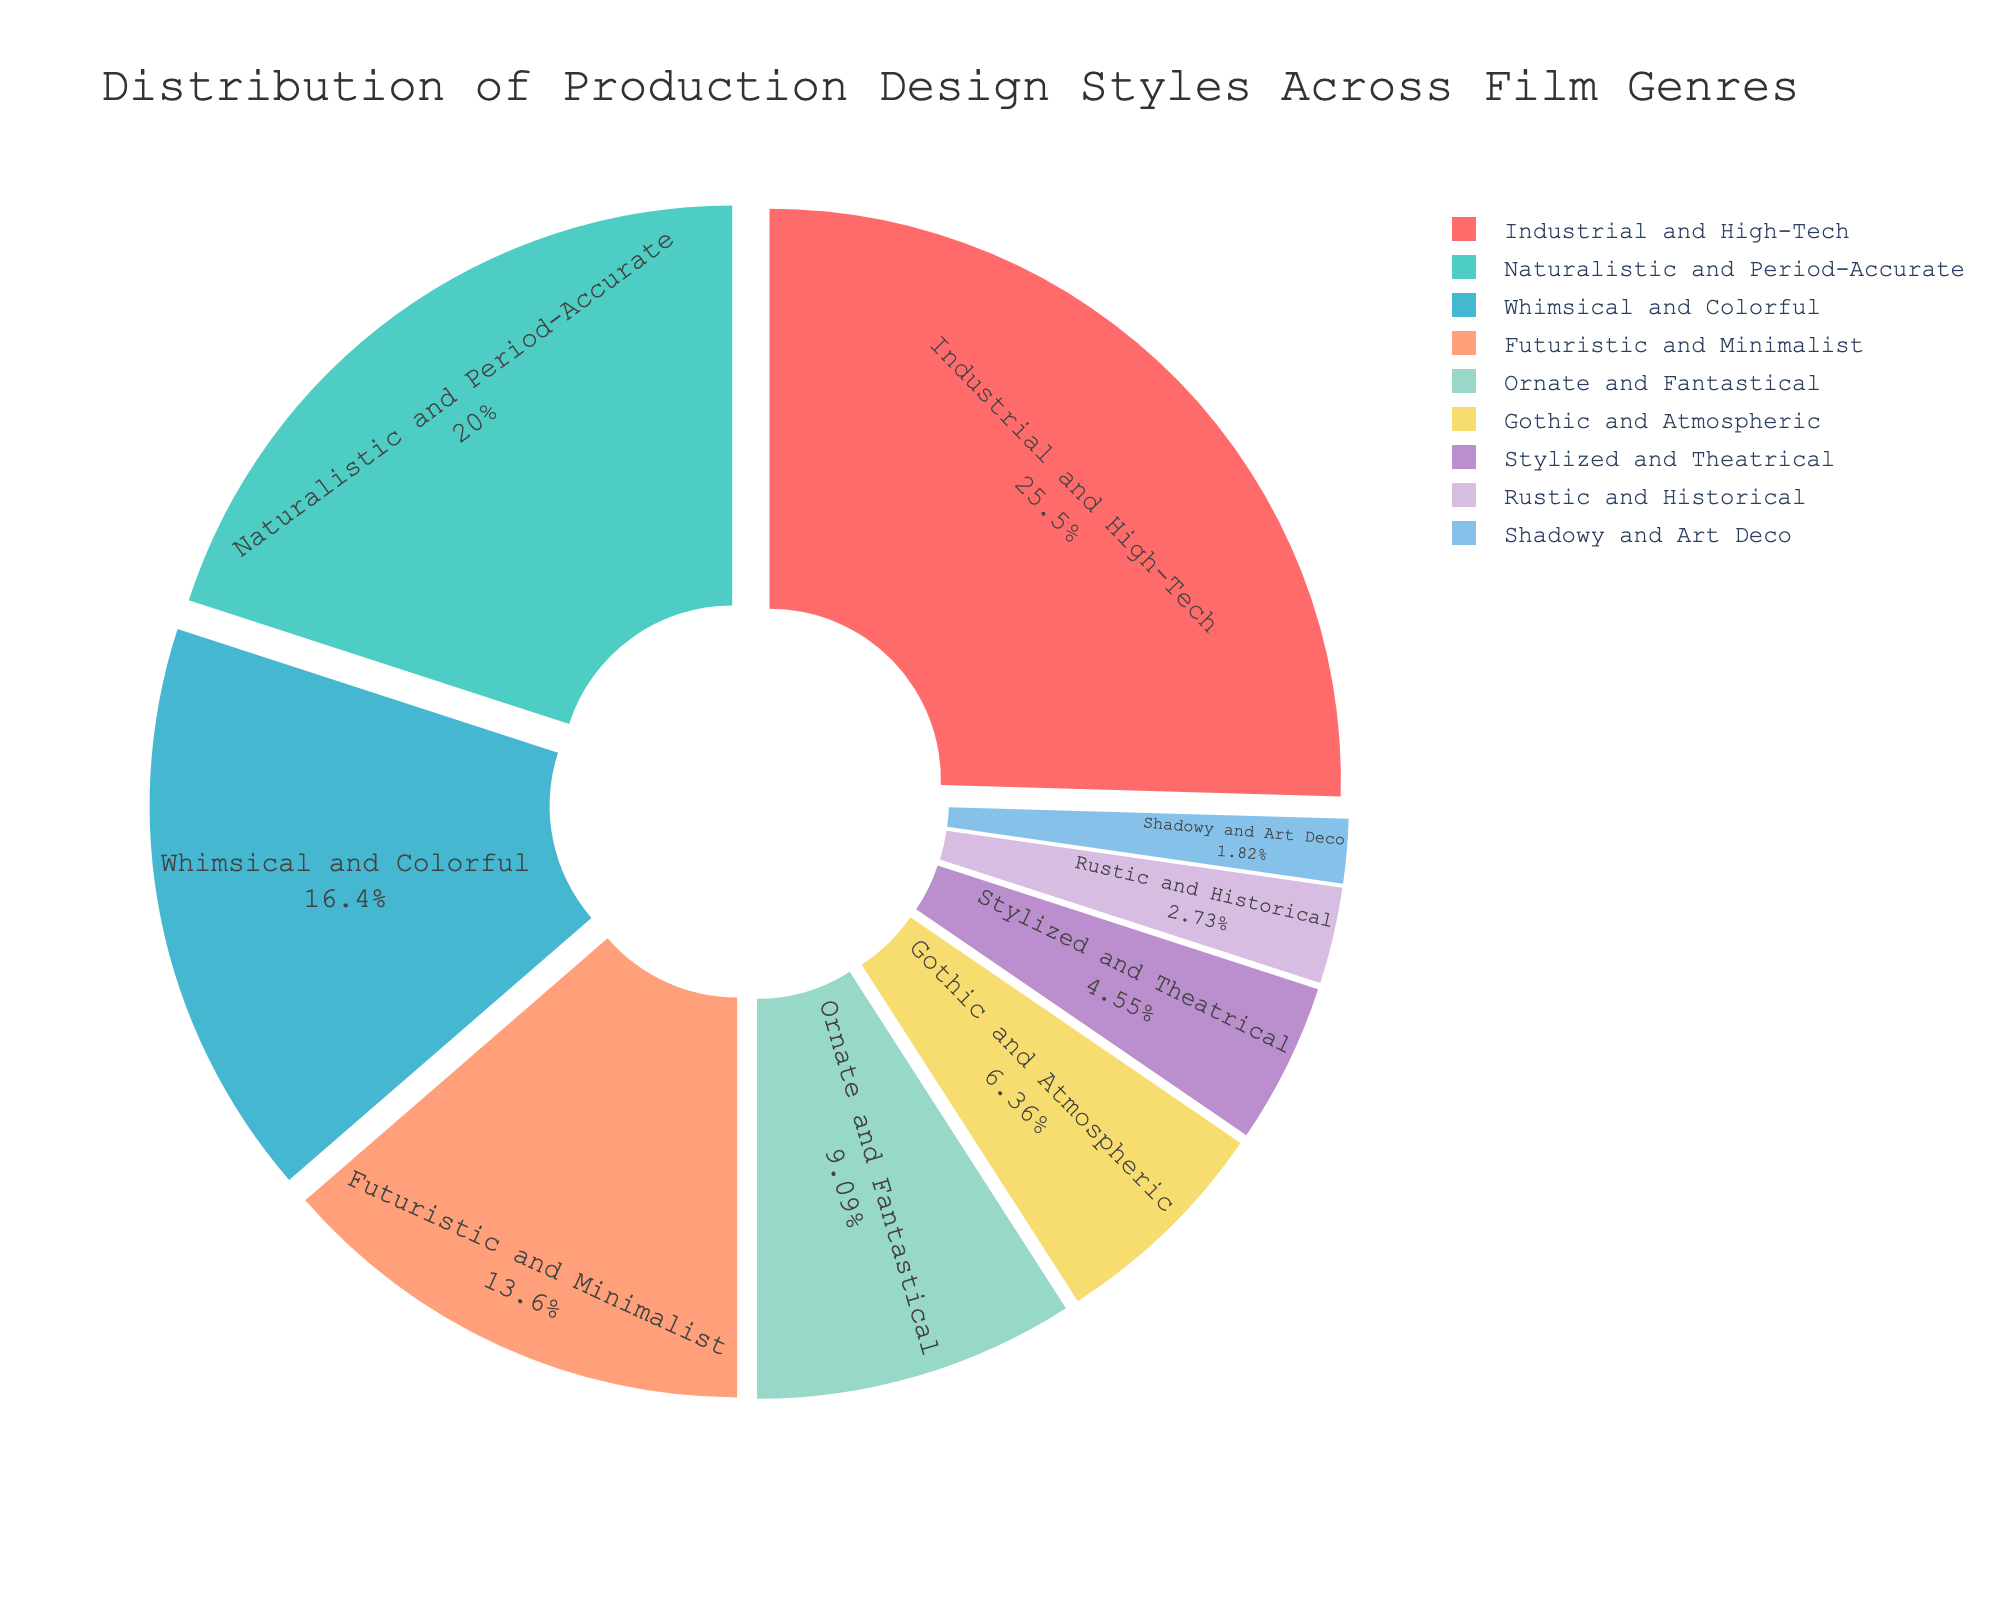Which production design style is most prevalent in the Action genre? The figure indicates that "Industrial and High-Tech" is the dominant production design style in the Action genre due to the large portion of the pie chart associated with it.
Answer: Industrial and High-Tech Which two production design styles have the smallest percentages? The smallest portions of the pie chart are "Shadowy and Art Deco" and "Rustic and Historical," which are associated with Noir and Western genres, respectively.
Answer: Shadowy and Art Deco, Rustic and Historical What is the combined percentage of "Whimsical and Colorful" and "Ornate and Fantastical" production design styles? Adding the percentages for "Whimsical and Colorful" (18%) and "Ornate and Fantastical" (10%) gives a total of 28%.
Answer: 28% Is "Gothic and Atmospheric" more prevalent than "Stylized and Theatrical"? The percentage for "Gothic and Atmospheric" (7%) is higher than that for "Stylized and Theatrical" (5%) as shown by their respective sections of the pie chart.
Answer: Yes Which genre has a 22% while contributing to an overall more period-accurate production design style? The Drama genre constitutes 22% of the pie chart with the "Naturalistic and Period-Accurate" production design style. This percentage and stylistic detail can be seen when hovering over the corresponding segment.
Answer: Drama How does the percentage of "Futuristic and Minimalist" compare to "Naturalistic and Period-Accurate"? "Futuristic and Minimalist" accounts for 15%, while "Naturalistic and Period-Accurate" is at 22%. Therefore, "Naturalistic and Period-Accurate" is higher by 7%.
Answer: 7% higher What is the visual appearance of the segment representing the Comedy genre style? The segment for "Whimsical and Colorful" production design (from the Comedy genre) is visually distinguished by a vibrant color and occupies 18% of the pie chart.
Answer: Vibrant, 18% To which film genre does the "Ornate and Fantastical" style belong? When hovering over the "Ornate and Fantastical" section of the pie chart, the associated genre indicated is Fantasy.
Answer: Fantasy What is the sum of the percentages of the three least prevalent production design styles? Adding the percentages of "Shadowy and Art Deco" (2%), "Rustic and Historical" (3%), and "Stylized and Theatrical" (5%) results in a total of 10%.
Answer: 10% How much more prevalent is the most common production design style than the least common one? The most common style "Industrial and High-Tech" is at 28%, while the least common, "Shadowy and Art Deco," is at 2%. The difference is 26%.
Answer: 26% 